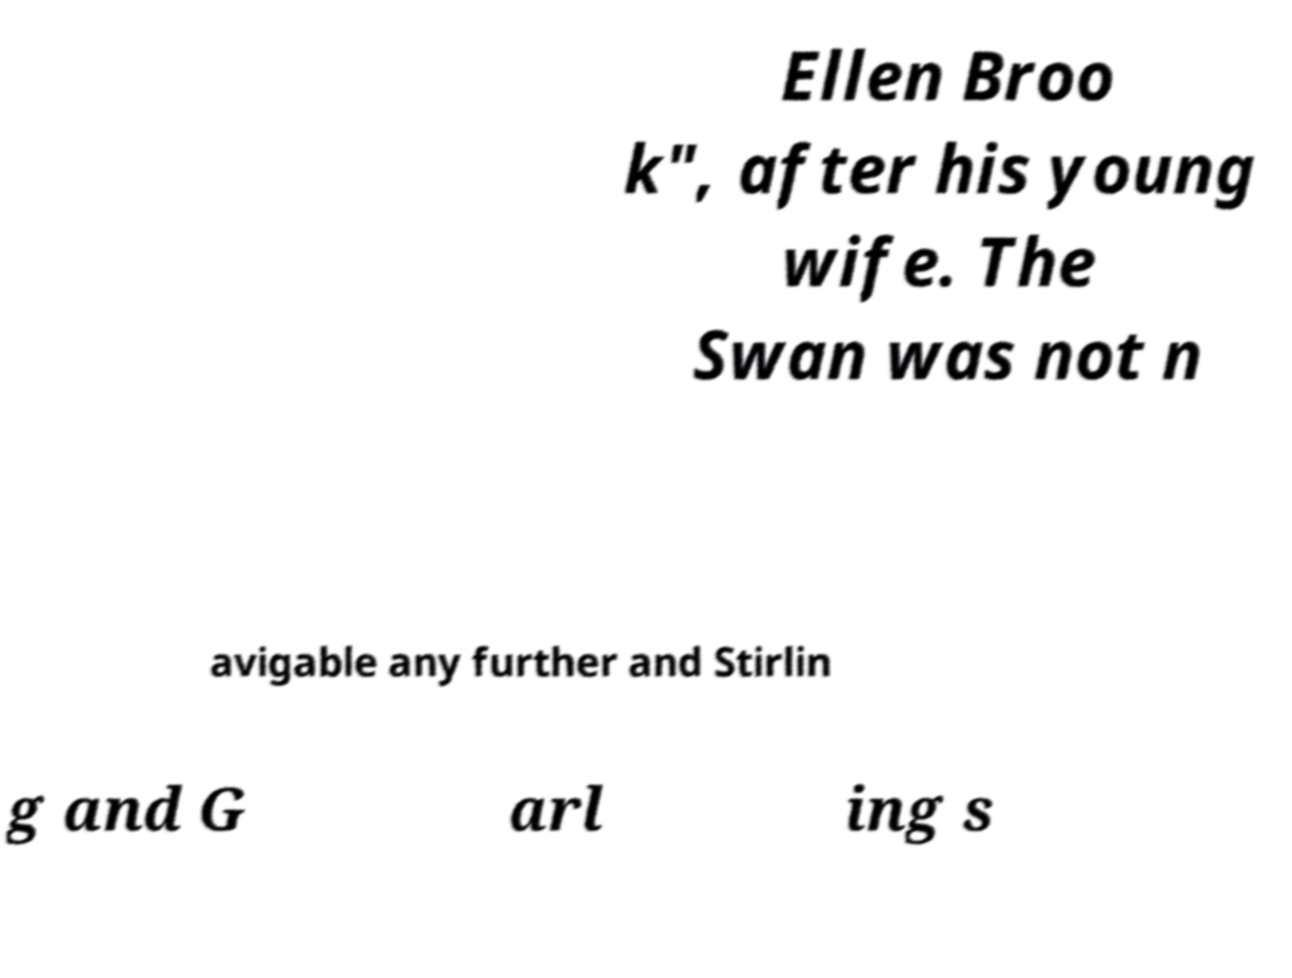Could you assist in decoding the text presented in this image and type it out clearly? Ellen Broo k", after his young wife. The Swan was not n avigable any further and Stirlin g and G arl ing s 